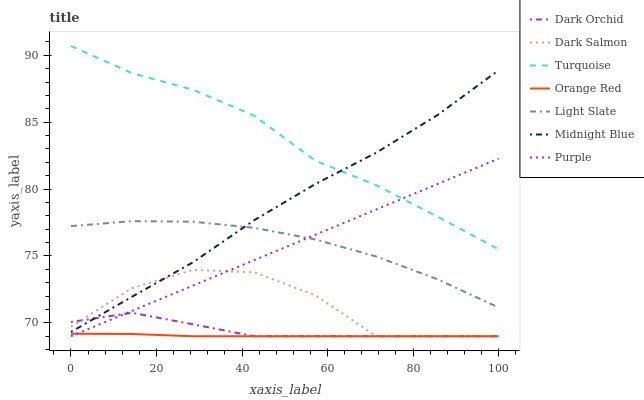Does Orange Red have the minimum area under the curve?
Answer yes or no. Yes. Does Turquoise have the maximum area under the curve?
Answer yes or no. Yes. Does Midnight Blue have the minimum area under the curve?
Answer yes or no. No. Does Midnight Blue have the maximum area under the curve?
Answer yes or no. No. Is Purple the smoothest?
Answer yes or no. Yes. Is Dark Salmon the roughest?
Answer yes or no. Yes. Is Midnight Blue the smoothest?
Answer yes or no. No. Is Midnight Blue the roughest?
Answer yes or no. No. Does Dark Salmon have the lowest value?
Answer yes or no. Yes. Does Midnight Blue have the lowest value?
Answer yes or no. No. Does Turquoise have the highest value?
Answer yes or no. Yes. Does Midnight Blue have the highest value?
Answer yes or no. No. Is Orange Red less than Turquoise?
Answer yes or no. Yes. Is Midnight Blue greater than Orange Red?
Answer yes or no. Yes. Does Midnight Blue intersect Dark Orchid?
Answer yes or no. Yes. Is Midnight Blue less than Dark Orchid?
Answer yes or no. No. Is Midnight Blue greater than Dark Orchid?
Answer yes or no. No. Does Orange Red intersect Turquoise?
Answer yes or no. No. 